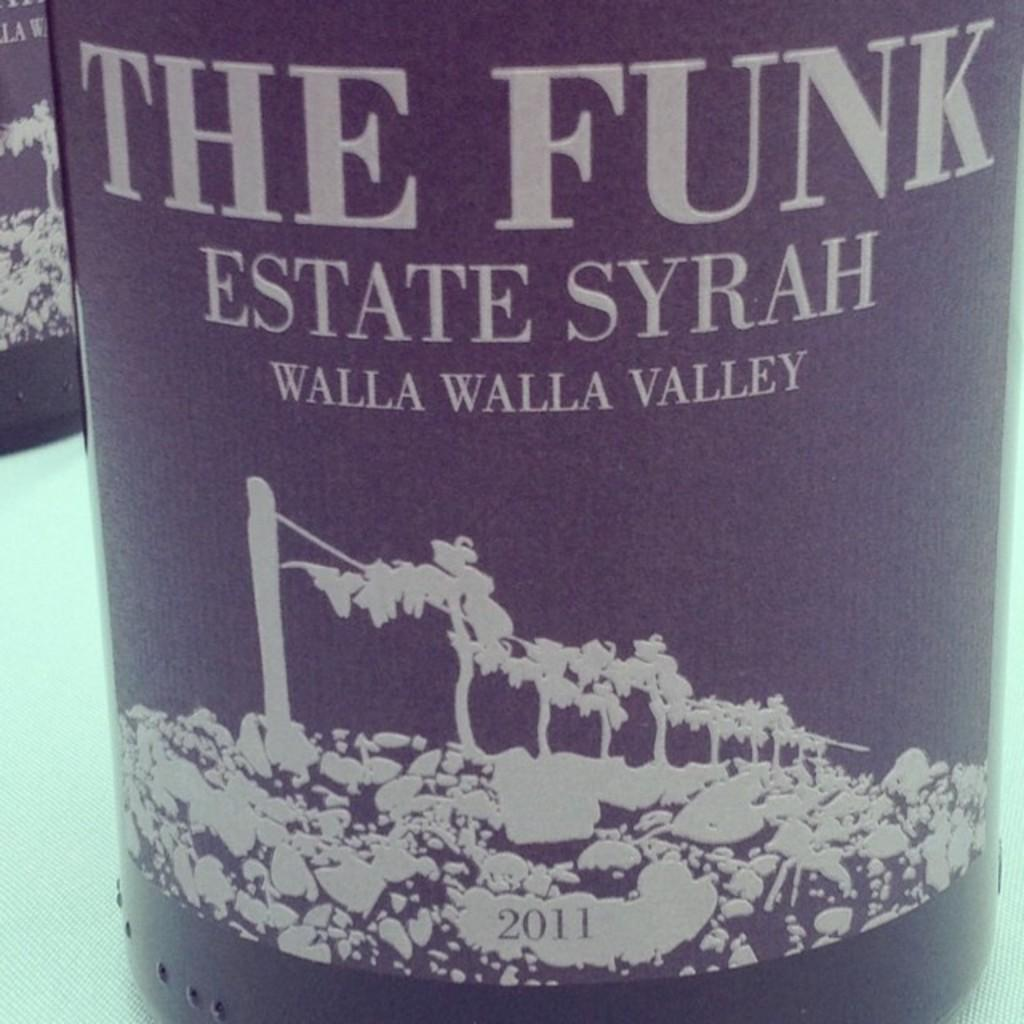<image>
Give a short and clear explanation of the subsequent image. the name The Funk which is on a bottle 